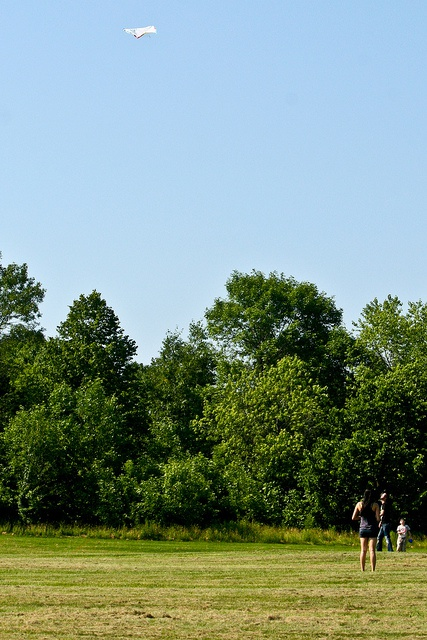Describe the objects in this image and their specific colors. I can see people in lightblue, black, maroon, tan, and olive tones, people in lightblue, black, olive, gray, and darkgray tones, people in lightblue, black, white, gray, and darkgreen tones, and kite in lightblue, white, darkgray, and brown tones in this image. 